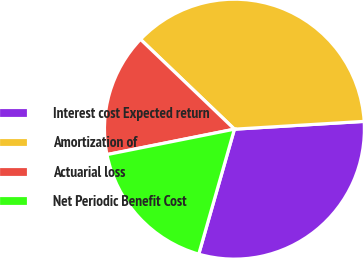Convert chart. <chart><loc_0><loc_0><loc_500><loc_500><pie_chart><fcel>Interest cost Expected return<fcel>Amortization of<fcel>Actuarial loss<fcel>Net Periodic Benefit Cost<nl><fcel>30.38%<fcel>36.9%<fcel>15.28%<fcel>17.44%<nl></chart> 